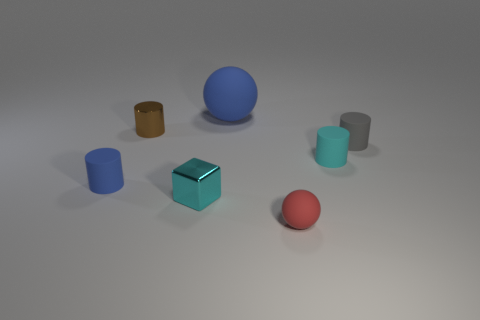Is there anything else that has the same size as the blue matte ball?
Keep it short and to the point. No. There is a cylinder that is the same color as the large rubber object; what is it made of?
Ensure brevity in your answer.  Rubber. How many other objects are there of the same shape as the red thing?
Your response must be concise. 1. Are there more tiny objects on the left side of the small red rubber sphere than tiny metallic things?
Offer a very short reply. Yes. What is the size of the cyan thing that is the same shape as the tiny gray thing?
Your answer should be very brief. Small. What is the shape of the cyan matte thing?
Keep it short and to the point. Cylinder. There is a gray thing that is the same size as the brown metal object; what is its shape?
Make the answer very short. Cylinder. Is there anything else that has the same color as the shiny cube?
Provide a succinct answer. Yes. There is a blue ball that is the same material as the gray cylinder; what is its size?
Make the answer very short. Large. Does the tiny brown object have the same shape as the tiny matte thing in front of the cyan shiny cube?
Offer a very short reply. No. 